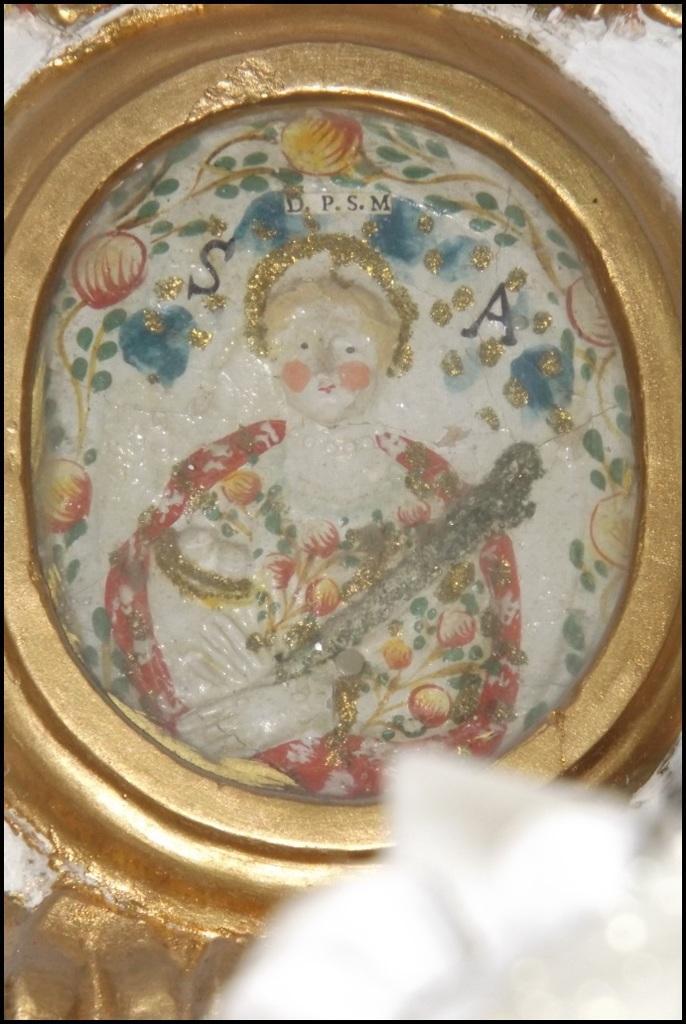Describe this image in one or two sentences. In this image there is a wall with a painting and carvings on it. 